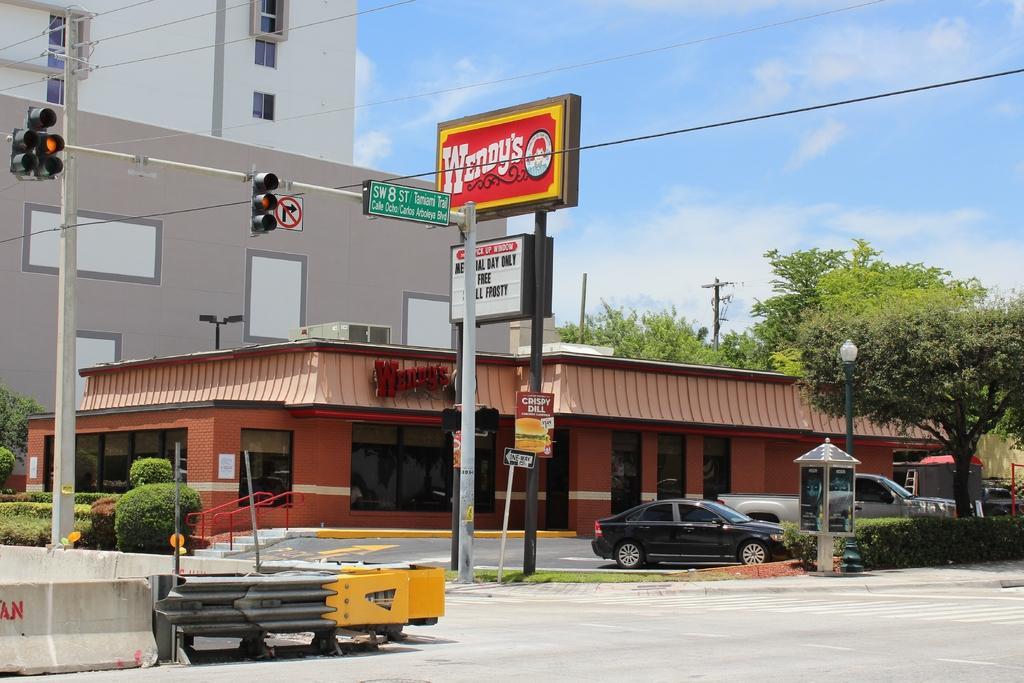Please provide a concise description of this image. In this image there is a store, buildings, poles, signal lights, boards, plants, trees, light pole, vehicle, road, cloudy sky and objects. Posters are on the walls. Something is written on the boards.   